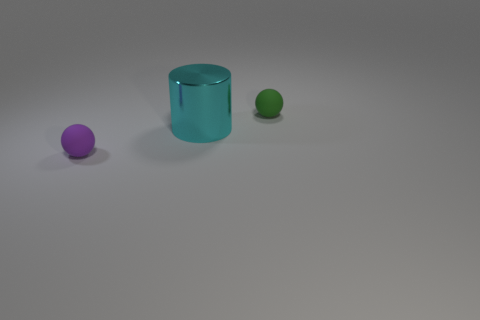Can you tell the relative sizes of the objects in the image? In the image, the cyan metal cylinder is the largest object in terms of height and volume. The purple ball is slightly larger than the green ball, making it the second largest in terms of diameter. How do these size differences affect the composition of the image? The varying sizes create a visual hierarchy and depth, drawing the viewer's eye from the larger cylinder at the center towards the smaller balls, enhancing the spatial balance and interest in the scene. 